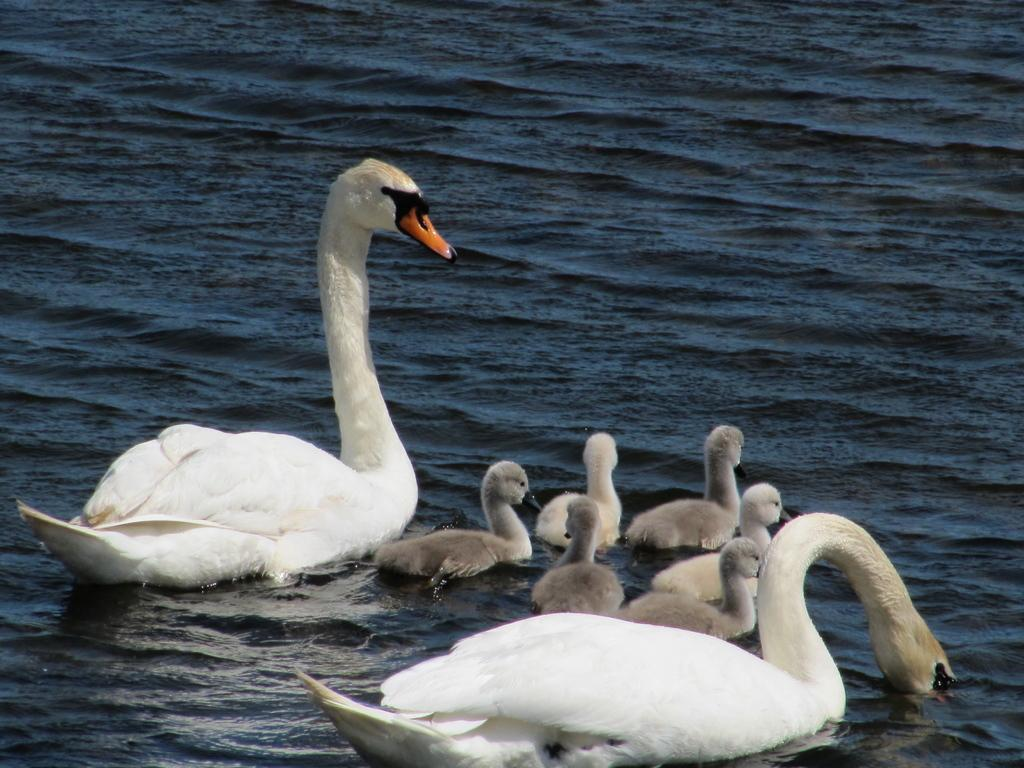What type of animals can be seen in the image? There are birds in the image. Are there any specific types of birds in the image? Yes, there are baby birds in the image. Where are the birds and baby birds located? The birds and baby birds are on the water. What type of veil can be seen covering the baby birds in the image? There is no veil present in the image; the baby birds are on the water without any covering. 